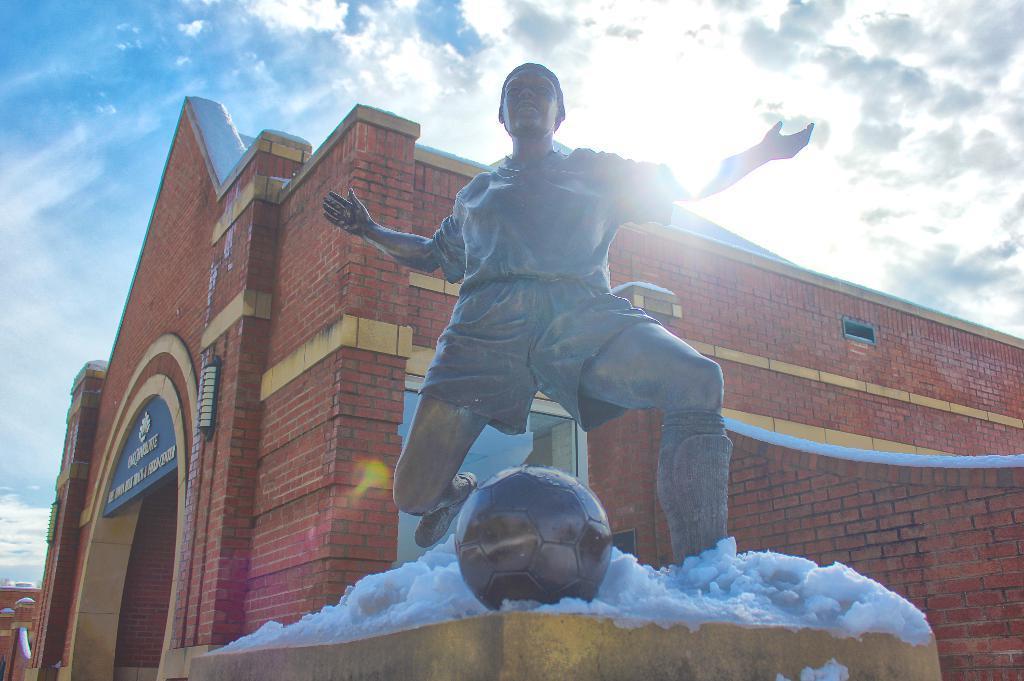In one or two sentences, can you explain what this image depicts? In front of the picture, we see the statue of the man playing football. Behind the statue, we see the building which is made up of red colored bricks. We see a blue color board with some text written on it. At the top of the picture, we see the sky, clouds and the sun. 